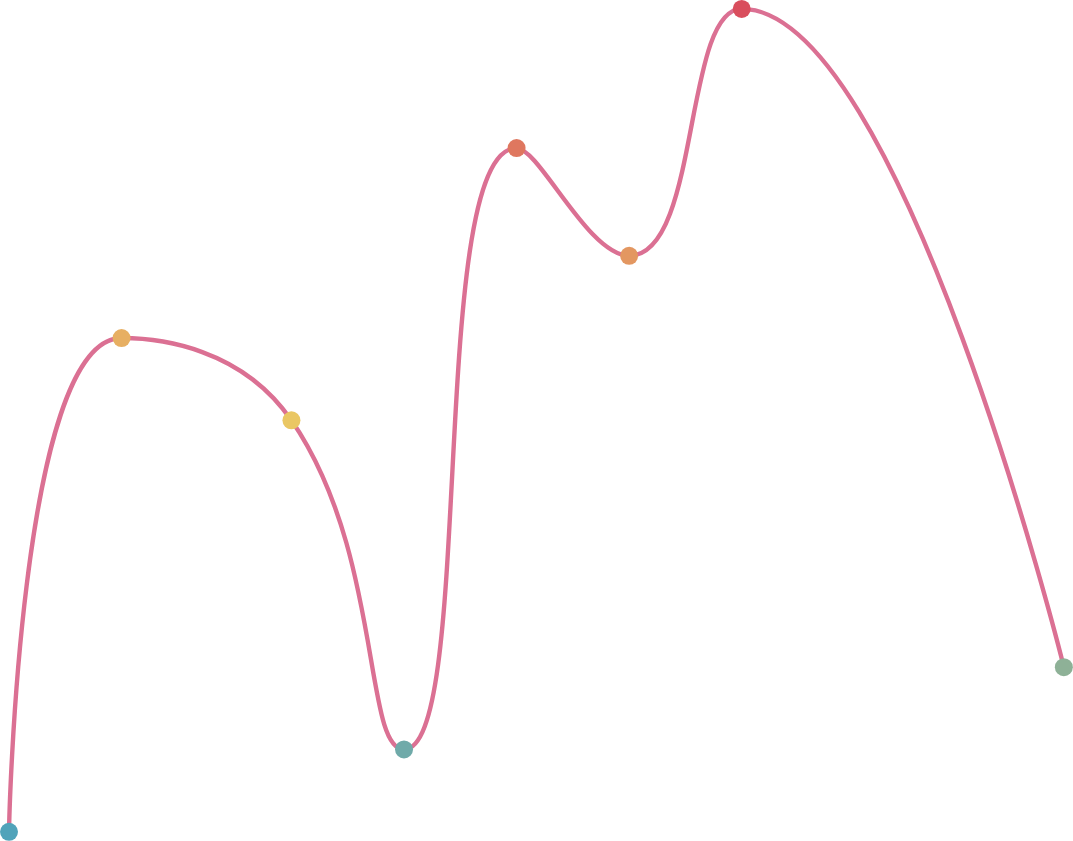Convert chart. <chart><loc_0><loc_0><loc_500><loc_500><line_chart><ecel><fcel>Unnamed: 1<nl><fcel>1617.39<fcel>0.47<nl><fcel>1695.21<fcel>7.67<nl><fcel>1812.65<fcel>6.47<nl><fcel>1890.47<fcel>1.67<nl><fcel>1968.29<fcel>10.44<nl><fcel>2046.11<fcel>8.87<nl><fcel>2123.93<fcel>12.47<nl><fcel>2346.63<fcel>2.87<nl><fcel>2424.45<fcel>5.27<nl><fcel>2502.27<fcel>4.07<nl></chart> 